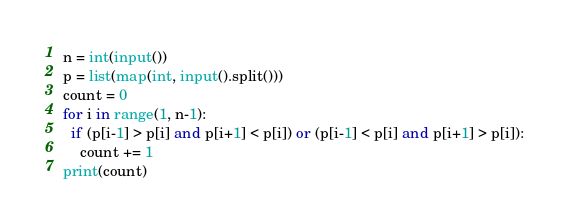<code> <loc_0><loc_0><loc_500><loc_500><_Python_>n = int(input())
p = list(map(int, input().split()))
count = 0
for i in range(1, n-1):
  if (p[i-1] > p[i] and p[i+1] < p[i]) or (p[i-1] < p[i] and p[i+1] > p[i]):
    count += 1
print(count)</code> 